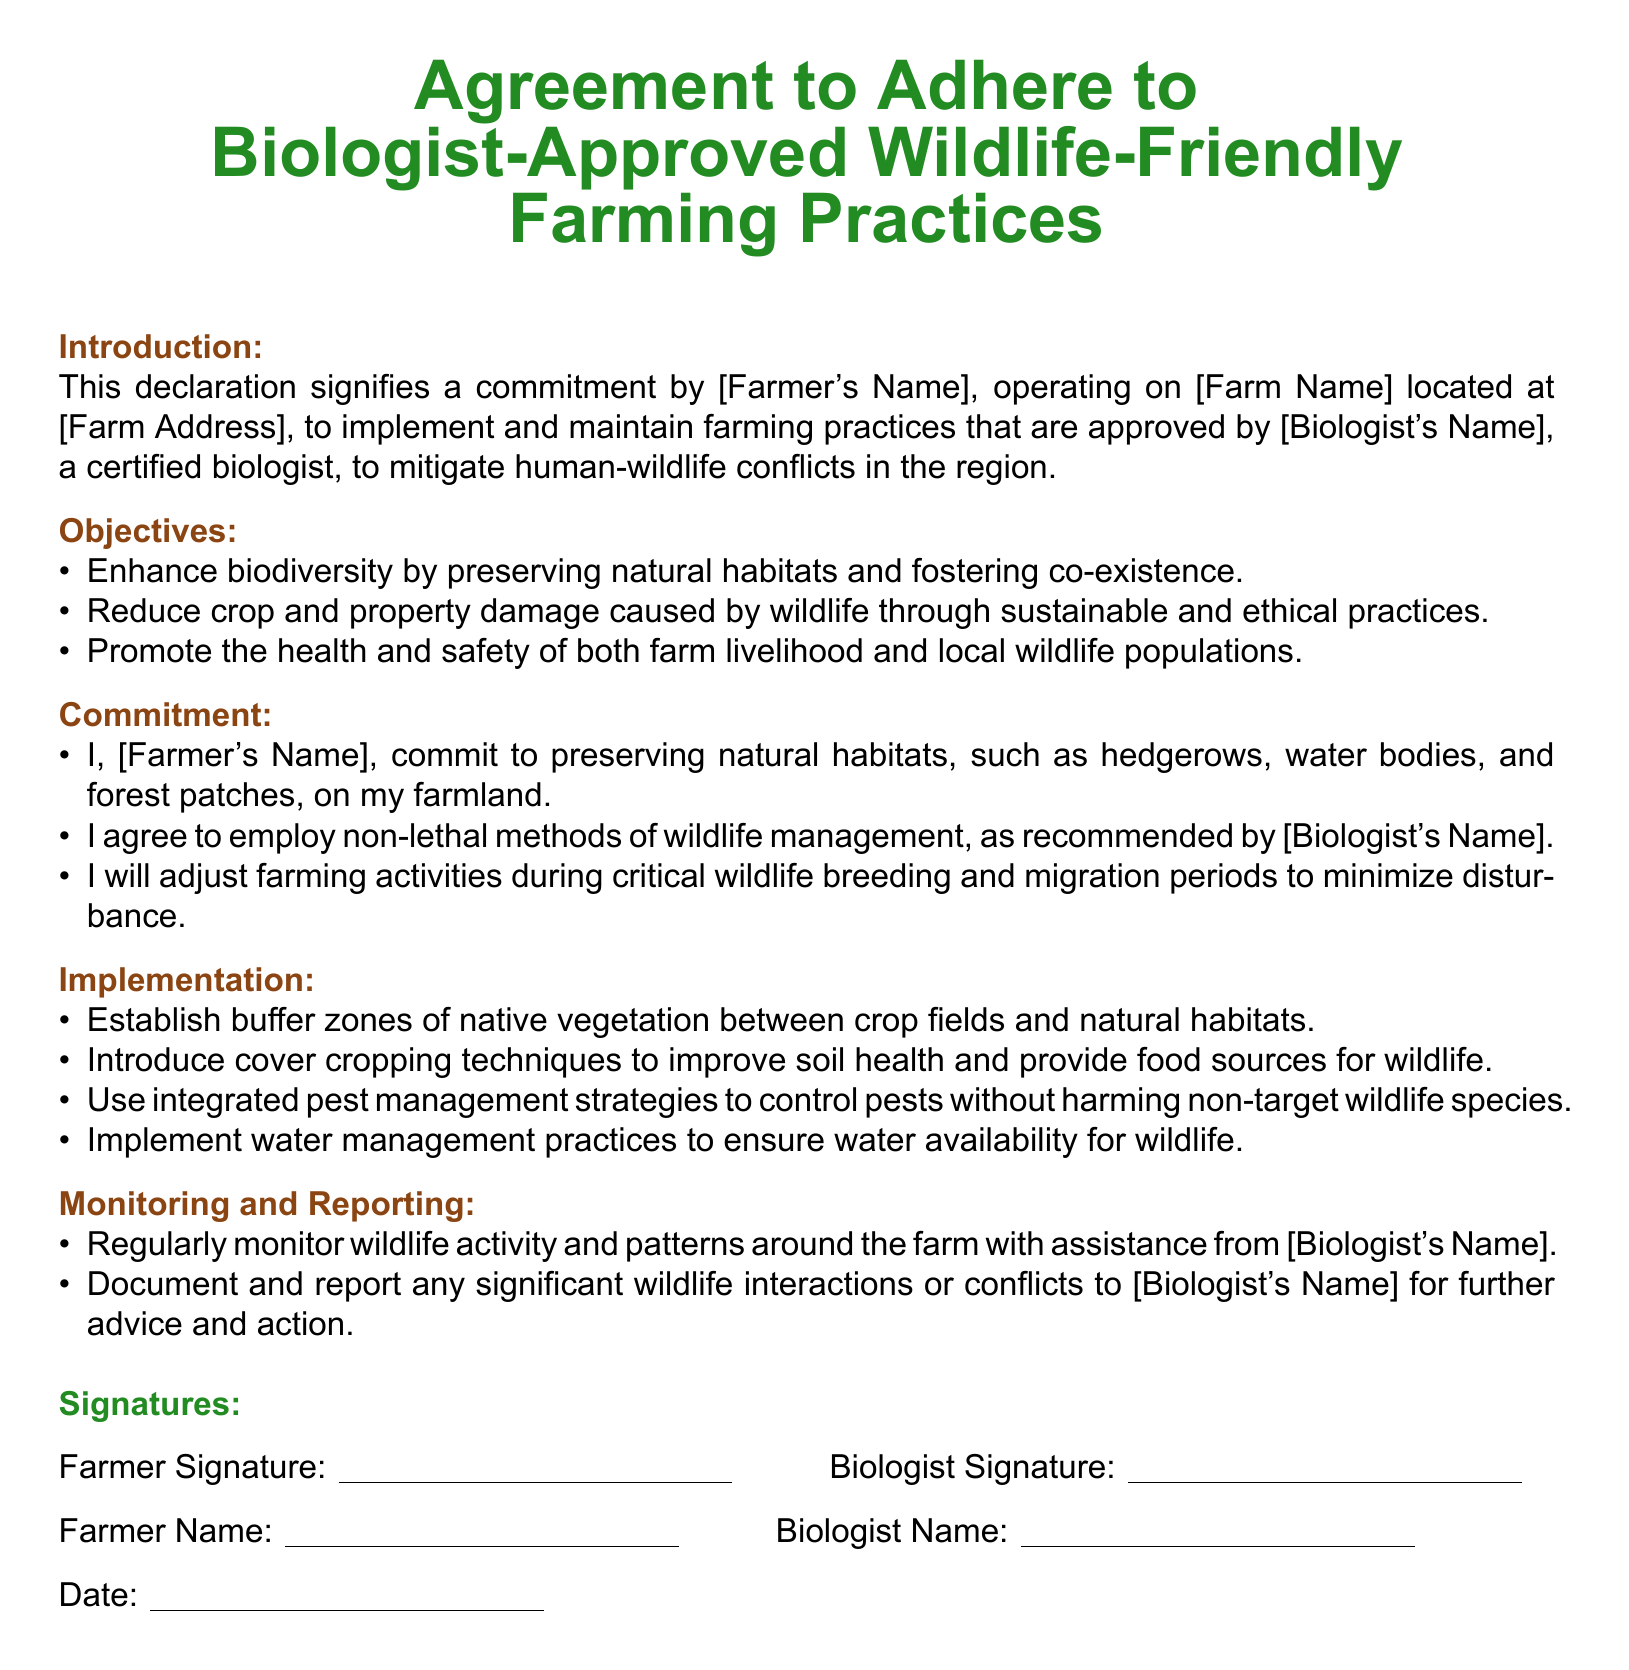What is the title of the document? The title is prominently featured at the top of the document, identifying its purpose regarding farming practices.
Answer: Agreement to Adhere to Biologist-Approved Wildlife-Friendly Farming Practices Who is the certified biologist mentioned in the document? The document specifies the biologist's name in the introduction section and in the commitment listing of practices to be followed.
Answer: [Biologist's Name] What is the main commitment of the farmer? The commitment section outlines specific actions that the farmer agrees to take for wildlife management and habitat preservation.
Answer: Preserving natural habitats What is one objective of the agreement? The objectives section lists the goals of the agreement, focusing on biodiversity and wildlife damage reduction.
Answer: Enhance biodiversity What type of methods does the farmer agree to employ for wildlife management? The commitment section specifically states the types of methods the farmer will agree to use to manage wildlife in an ethical manner.
Answer: Non-lethal methods Which farming practice involves introducing native vegetation? The implementation section highlights specific practices that will be adopted to support wildlife and farm health.
Answer: Establish buffer zones What must the farmer regularly monitor according to the document? The monitoring section specifies a particular activity to keep track of wildlife presence and interaction around the farm.
Answer: Wildlife activity How will the farmer report significant wildlife interactions? The monitoring section includes procedures to document and communicate wildlife interactions for assistance.
Answer: Document and report What must be included in the signature section? The signature section requires specific identifiers that validate the agreement's authenticity from both parties.
Answer: Farmer Signature and Biologist Signature 